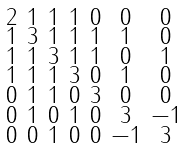<formula> <loc_0><loc_0><loc_500><loc_500>\begin{smallmatrix} 2 & 1 & 1 & 1 & 0 & 0 & 0 \\ 1 & 3 & 1 & 1 & 1 & 1 & 0 \\ 1 & 1 & 3 & 1 & 1 & 0 & 1 \\ 1 & 1 & 1 & 3 & 0 & 1 & 0 \\ 0 & 1 & 1 & 0 & 3 & 0 & 0 \\ 0 & 1 & 0 & 1 & 0 & 3 & - 1 \\ 0 & 0 & 1 & 0 & 0 & - 1 & 3 \end{smallmatrix}</formula> 